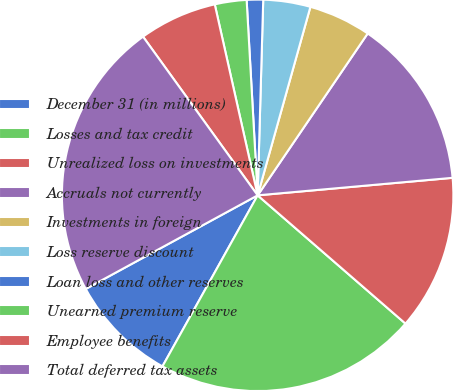<chart> <loc_0><loc_0><loc_500><loc_500><pie_chart><fcel>December 31 (in millions)<fcel>Losses and tax credit<fcel>Unrealized loss on investments<fcel>Accruals not currently<fcel>Investments in foreign<fcel>Loss reserve discount<fcel>Loan loss and other reserves<fcel>Unearned premium reserve<fcel>Employee benefits<fcel>Total deferred tax assets<nl><fcel>8.98%<fcel>21.71%<fcel>12.8%<fcel>14.07%<fcel>5.16%<fcel>3.89%<fcel>1.35%<fcel>2.62%<fcel>6.44%<fcel>22.98%<nl></chart> 